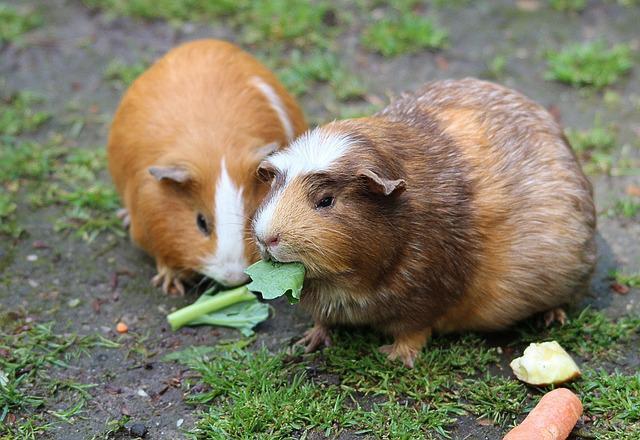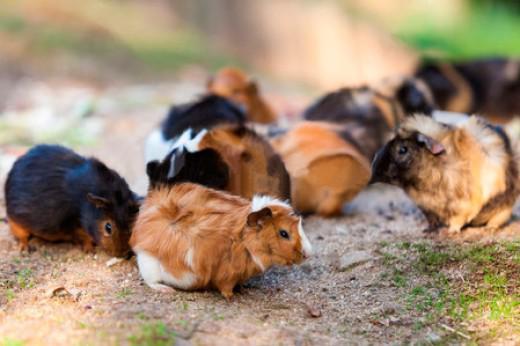The first image is the image on the left, the second image is the image on the right. Examine the images to the left and right. Is the description "An image shows a larger guinea pig with a smaller pet rodent on a fabric ground surface." accurate? Answer yes or no. No. The first image is the image on the left, the second image is the image on the right. Considering the images on both sides, is "The rodents in the image on the left are sitting on green grass." valid? Answer yes or no. Yes. 